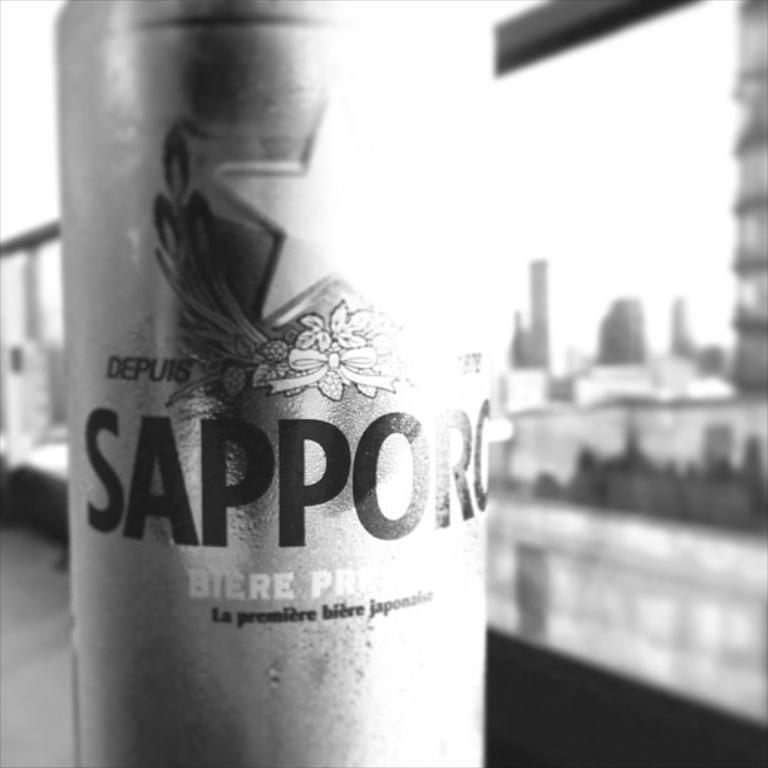<image>
Describe the image concisely. Bottle of Sapporo outdoors on a bridge near a city. 